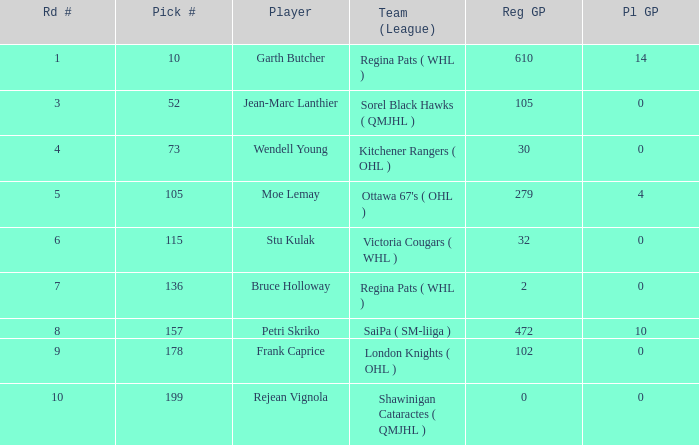What is the sum number of Pl GP when the pick number is 178 and the road number is bigger than 9? 0.0. 